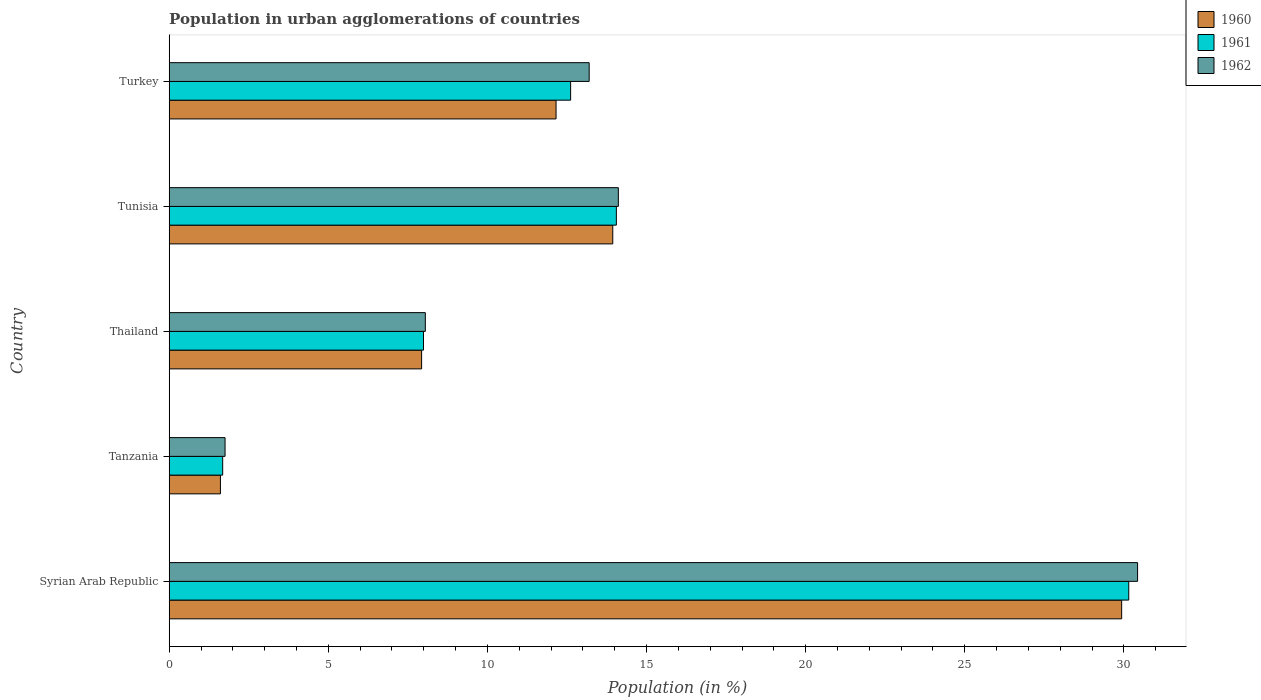How many different coloured bars are there?
Provide a short and direct response. 3. How many groups of bars are there?
Your answer should be very brief. 5. Are the number of bars per tick equal to the number of legend labels?
Offer a very short reply. Yes. How many bars are there on the 5th tick from the top?
Make the answer very short. 3. What is the label of the 2nd group of bars from the top?
Offer a very short reply. Tunisia. In how many cases, is the number of bars for a given country not equal to the number of legend labels?
Ensure brevity in your answer.  0. What is the percentage of population in urban agglomerations in 1961 in Turkey?
Make the answer very short. 12.61. Across all countries, what is the maximum percentage of population in urban agglomerations in 1961?
Your answer should be very brief. 30.15. Across all countries, what is the minimum percentage of population in urban agglomerations in 1961?
Your answer should be very brief. 1.68. In which country was the percentage of population in urban agglomerations in 1962 maximum?
Offer a very short reply. Syrian Arab Republic. In which country was the percentage of population in urban agglomerations in 1962 minimum?
Give a very brief answer. Tanzania. What is the total percentage of population in urban agglomerations in 1960 in the graph?
Make the answer very short. 65.56. What is the difference between the percentage of population in urban agglomerations in 1961 in Syrian Arab Republic and that in Turkey?
Offer a very short reply. 17.54. What is the difference between the percentage of population in urban agglomerations in 1960 in Thailand and the percentage of population in urban agglomerations in 1962 in Turkey?
Keep it short and to the point. -5.27. What is the average percentage of population in urban agglomerations in 1960 per country?
Offer a terse response. 13.11. What is the difference between the percentage of population in urban agglomerations in 1961 and percentage of population in urban agglomerations in 1960 in Tanzania?
Ensure brevity in your answer.  0.07. In how many countries, is the percentage of population in urban agglomerations in 1962 greater than 27 %?
Make the answer very short. 1. What is the ratio of the percentage of population in urban agglomerations in 1961 in Syrian Arab Republic to that in Thailand?
Your answer should be very brief. 3.77. Is the difference between the percentage of population in urban agglomerations in 1961 in Tanzania and Tunisia greater than the difference between the percentage of population in urban agglomerations in 1960 in Tanzania and Tunisia?
Keep it short and to the point. No. What is the difference between the highest and the second highest percentage of population in urban agglomerations in 1960?
Your answer should be compact. 15.99. What is the difference between the highest and the lowest percentage of population in urban agglomerations in 1961?
Provide a short and direct response. 28.47. In how many countries, is the percentage of population in urban agglomerations in 1961 greater than the average percentage of population in urban agglomerations in 1961 taken over all countries?
Provide a short and direct response. 2. What does the 3rd bar from the top in Tanzania represents?
Offer a very short reply. 1960. How many bars are there?
Your response must be concise. 15. Are all the bars in the graph horizontal?
Offer a terse response. Yes. What is the difference between two consecutive major ticks on the X-axis?
Provide a succinct answer. 5. Does the graph contain any zero values?
Your answer should be very brief. No. Does the graph contain grids?
Provide a succinct answer. No. Where does the legend appear in the graph?
Your answer should be very brief. Top right. How many legend labels are there?
Give a very brief answer. 3. What is the title of the graph?
Your answer should be compact. Population in urban agglomerations of countries. What is the label or title of the X-axis?
Ensure brevity in your answer.  Population (in %). What is the Population (in %) in 1960 in Syrian Arab Republic?
Your response must be concise. 29.93. What is the Population (in %) of 1961 in Syrian Arab Republic?
Your response must be concise. 30.15. What is the Population (in %) in 1962 in Syrian Arab Republic?
Provide a succinct answer. 30.43. What is the Population (in %) in 1960 in Tanzania?
Ensure brevity in your answer.  1.61. What is the Population (in %) in 1961 in Tanzania?
Give a very brief answer. 1.68. What is the Population (in %) in 1962 in Tanzania?
Keep it short and to the point. 1.76. What is the Population (in %) in 1960 in Thailand?
Provide a short and direct response. 7.93. What is the Population (in %) in 1961 in Thailand?
Offer a terse response. 7.99. What is the Population (in %) in 1962 in Thailand?
Your response must be concise. 8.05. What is the Population (in %) of 1960 in Tunisia?
Provide a succinct answer. 13.94. What is the Population (in %) in 1961 in Tunisia?
Offer a terse response. 14.05. What is the Population (in %) in 1962 in Tunisia?
Provide a short and direct response. 14.11. What is the Population (in %) in 1960 in Turkey?
Provide a short and direct response. 12.16. What is the Population (in %) in 1961 in Turkey?
Your answer should be very brief. 12.61. What is the Population (in %) of 1962 in Turkey?
Give a very brief answer. 13.2. Across all countries, what is the maximum Population (in %) of 1960?
Offer a terse response. 29.93. Across all countries, what is the maximum Population (in %) of 1961?
Your answer should be very brief. 30.15. Across all countries, what is the maximum Population (in %) of 1962?
Give a very brief answer. 30.43. Across all countries, what is the minimum Population (in %) of 1960?
Provide a short and direct response. 1.61. Across all countries, what is the minimum Population (in %) of 1961?
Ensure brevity in your answer.  1.68. Across all countries, what is the minimum Population (in %) of 1962?
Your response must be concise. 1.76. What is the total Population (in %) of 1960 in the graph?
Offer a very short reply. 65.56. What is the total Population (in %) of 1961 in the graph?
Ensure brevity in your answer.  66.49. What is the total Population (in %) in 1962 in the graph?
Your response must be concise. 67.54. What is the difference between the Population (in %) of 1960 in Syrian Arab Republic and that in Tanzania?
Make the answer very short. 28.32. What is the difference between the Population (in %) in 1961 in Syrian Arab Republic and that in Tanzania?
Give a very brief answer. 28.47. What is the difference between the Population (in %) in 1962 in Syrian Arab Republic and that in Tanzania?
Offer a very short reply. 28.67. What is the difference between the Population (in %) of 1960 in Syrian Arab Republic and that in Thailand?
Your answer should be compact. 22. What is the difference between the Population (in %) in 1961 in Syrian Arab Republic and that in Thailand?
Your answer should be compact. 22.16. What is the difference between the Population (in %) of 1962 in Syrian Arab Republic and that in Thailand?
Ensure brevity in your answer.  22.38. What is the difference between the Population (in %) of 1960 in Syrian Arab Republic and that in Tunisia?
Provide a short and direct response. 15.99. What is the difference between the Population (in %) in 1961 in Syrian Arab Republic and that in Tunisia?
Provide a succinct answer. 16.1. What is the difference between the Population (in %) of 1962 in Syrian Arab Republic and that in Tunisia?
Your response must be concise. 16.32. What is the difference between the Population (in %) of 1960 in Syrian Arab Republic and that in Turkey?
Your answer should be very brief. 17.77. What is the difference between the Population (in %) of 1961 in Syrian Arab Republic and that in Turkey?
Your answer should be compact. 17.54. What is the difference between the Population (in %) in 1962 in Syrian Arab Republic and that in Turkey?
Offer a very short reply. 17.23. What is the difference between the Population (in %) of 1960 in Tanzania and that in Thailand?
Your answer should be compact. -6.32. What is the difference between the Population (in %) of 1961 in Tanzania and that in Thailand?
Ensure brevity in your answer.  -6.31. What is the difference between the Population (in %) of 1962 in Tanzania and that in Thailand?
Ensure brevity in your answer.  -6.29. What is the difference between the Population (in %) in 1960 in Tanzania and that in Tunisia?
Your answer should be compact. -12.33. What is the difference between the Population (in %) in 1961 in Tanzania and that in Tunisia?
Your response must be concise. -12.37. What is the difference between the Population (in %) of 1962 in Tanzania and that in Tunisia?
Provide a succinct answer. -12.36. What is the difference between the Population (in %) of 1960 in Tanzania and that in Turkey?
Give a very brief answer. -10.55. What is the difference between the Population (in %) of 1961 in Tanzania and that in Turkey?
Keep it short and to the point. -10.93. What is the difference between the Population (in %) of 1962 in Tanzania and that in Turkey?
Ensure brevity in your answer.  -11.44. What is the difference between the Population (in %) in 1960 in Thailand and that in Tunisia?
Ensure brevity in your answer.  -6.01. What is the difference between the Population (in %) of 1961 in Thailand and that in Tunisia?
Offer a terse response. -6.06. What is the difference between the Population (in %) of 1962 in Thailand and that in Tunisia?
Your response must be concise. -6.07. What is the difference between the Population (in %) of 1960 in Thailand and that in Turkey?
Offer a very short reply. -4.22. What is the difference between the Population (in %) of 1961 in Thailand and that in Turkey?
Keep it short and to the point. -4.62. What is the difference between the Population (in %) of 1962 in Thailand and that in Turkey?
Make the answer very short. -5.15. What is the difference between the Population (in %) in 1960 in Tunisia and that in Turkey?
Make the answer very short. 1.78. What is the difference between the Population (in %) of 1961 in Tunisia and that in Turkey?
Offer a terse response. 1.44. What is the difference between the Population (in %) in 1960 in Syrian Arab Republic and the Population (in %) in 1961 in Tanzania?
Make the answer very short. 28.25. What is the difference between the Population (in %) of 1960 in Syrian Arab Republic and the Population (in %) of 1962 in Tanzania?
Offer a very short reply. 28.17. What is the difference between the Population (in %) of 1961 in Syrian Arab Republic and the Population (in %) of 1962 in Tanzania?
Offer a very short reply. 28.4. What is the difference between the Population (in %) of 1960 in Syrian Arab Republic and the Population (in %) of 1961 in Thailand?
Offer a terse response. 21.94. What is the difference between the Population (in %) of 1960 in Syrian Arab Republic and the Population (in %) of 1962 in Thailand?
Keep it short and to the point. 21.88. What is the difference between the Population (in %) in 1961 in Syrian Arab Republic and the Population (in %) in 1962 in Thailand?
Offer a very short reply. 22.1. What is the difference between the Population (in %) in 1960 in Syrian Arab Republic and the Population (in %) in 1961 in Tunisia?
Your answer should be very brief. 15.88. What is the difference between the Population (in %) of 1960 in Syrian Arab Republic and the Population (in %) of 1962 in Tunisia?
Your answer should be compact. 15.82. What is the difference between the Population (in %) of 1961 in Syrian Arab Republic and the Population (in %) of 1962 in Tunisia?
Provide a succinct answer. 16.04. What is the difference between the Population (in %) of 1960 in Syrian Arab Republic and the Population (in %) of 1961 in Turkey?
Provide a short and direct response. 17.31. What is the difference between the Population (in %) in 1960 in Syrian Arab Republic and the Population (in %) in 1962 in Turkey?
Give a very brief answer. 16.73. What is the difference between the Population (in %) of 1961 in Syrian Arab Republic and the Population (in %) of 1962 in Turkey?
Ensure brevity in your answer.  16.95. What is the difference between the Population (in %) in 1960 in Tanzania and the Population (in %) in 1961 in Thailand?
Offer a terse response. -6.38. What is the difference between the Population (in %) in 1960 in Tanzania and the Population (in %) in 1962 in Thailand?
Your answer should be very brief. -6.44. What is the difference between the Population (in %) in 1961 in Tanzania and the Population (in %) in 1962 in Thailand?
Offer a very short reply. -6.37. What is the difference between the Population (in %) of 1960 in Tanzania and the Population (in %) of 1961 in Tunisia?
Give a very brief answer. -12.44. What is the difference between the Population (in %) of 1960 in Tanzania and the Population (in %) of 1962 in Tunisia?
Give a very brief answer. -12.5. What is the difference between the Population (in %) of 1961 in Tanzania and the Population (in %) of 1962 in Tunisia?
Give a very brief answer. -12.43. What is the difference between the Population (in %) in 1960 in Tanzania and the Population (in %) in 1961 in Turkey?
Offer a very short reply. -11. What is the difference between the Population (in %) in 1960 in Tanzania and the Population (in %) in 1962 in Turkey?
Offer a very short reply. -11.59. What is the difference between the Population (in %) in 1961 in Tanzania and the Population (in %) in 1962 in Turkey?
Offer a very short reply. -11.52. What is the difference between the Population (in %) in 1960 in Thailand and the Population (in %) in 1961 in Tunisia?
Provide a succinct answer. -6.12. What is the difference between the Population (in %) of 1960 in Thailand and the Population (in %) of 1962 in Tunisia?
Your answer should be compact. -6.18. What is the difference between the Population (in %) of 1961 in Thailand and the Population (in %) of 1962 in Tunisia?
Offer a terse response. -6.12. What is the difference between the Population (in %) in 1960 in Thailand and the Population (in %) in 1961 in Turkey?
Give a very brief answer. -4.68. What is the difference between the Population (in %) in 1960 in Thailand and the Population (in %) in 1962 in Turkey?
Give a very brief answer. -5.27. What is the difference between the Population (in %) in 1961 in Thailand and the Population (in %) in 1962 in Turkey?
Ensure brevity in your answer.  -5.21. What is the difference between the Population (in %) in 1960 in Tunisia and the Population (in %) in 1961 in Turkey?
Offer a very short reply. 1.32. What is the difference between the Population (in %) in 1960 in Tunisia and the Population (in %) in 1962 in Turkey?
Provide a short and direct response. 0.74. What is the difference between the Population (in %) of 1961 in Tunisia and the Population (in %) of 1962 in Turkey?
Your answer should be very brief. 0.85. What is the average Population (in %) in 1960 per country?
Give a very brief answer. 13.11. What is the average Population (in %) of 1961 per country?
Keep it short and to the point. 13.3. What is the average Population (in %) of 1962 per country?
Your response must be concise. 13.51. What is the difference between the Population (in %) of 1960 and Population (in %) of 1961 in Syrian Arab Republic?
Provide a succinct answer. -0.22. What is the difference between the Population (in %) of 1960 and Population (in %) of 1962 in Syrian Arab Republic?
Provide a succinct answer. -0.5. What is the difference between the Population (in %) of 1961 and Population (in %) of 1962 in Syrian Arab Republic?
Provide a short and direct response. -0.28. What is the difference between the Population (in %) in 1960 and Population (in %) in 1961 in Tanzania?
Your answer should be compact. -0.07. What is the difference between the Population (in %) of 1960 and Population (in %) of 1962 in Tanzania?
Offer a very short reply. -0.15. What is the difference between the Population (in %) of 1961 and Population (in %) of 1962 in Tanzania?
Ensure brevity in your answer.  -0.07. What is the difference between the Population (in %) of 1960 and Population (in %) of 1961 in Thailand?
Keep it short and to the point. -0.06. What is the difference between the Population (in %) of 1960 and Population (in %) of 1962 in Thailand?
Make the answer very short. -0.12. What is the difference between the Population (in %) of 1961 and Population (in %) of 1962 in Thailand?
Make the answer very short. -0.06. What is the difference between the Population (in %) in 1960 and Population (in %) in 1961 in Tunisia?
Keep it short and to the point. -0.11. What is the difference between the Population (in %) in 1960 and Population (in %) in 1962 in Tunisia?
Your answer should be compact. -0.18. What is the difference between the Population (in %) in 1961 and Population (in %) in 1962 in Tunisia?
Your answer should be very brief. -0.06. What is the difference between the Population (in %) of 1960 and Population (in %) of 1961 in Turkey?
Give a very brief answer. -0.46. What is the difference between the Population (in %) of 1960 and Population (in %) of 1962 in Turkey?
Offer a very short reply. -1.04. What is the difference between the Population (in %) in 1961 and Population (in %) in 1962 in Turkey?
Provide a short and direct response. -0.58. What is the ratio of the Population (in %) in 1960 in Syrian Arab Republic to that in Tanzania?
Provide a short and direct response. 18.6. What is the ratio of the Population (in %) of 1961 in Syrian Arab Republic to that in Tanzania?
Provide a succinct answer. 17.94. What is the ratio of the Population (in %) in 1962 in Syrian Arab Republic to that in Tanzania?
Offer a very short reply. 17.34. What is the ratio of the Population (in %) of 1960 in Syrian Arab Republic to that in Thailand?
Offer a terse response. 3.77. What is the ratio of the Population (in %) of 1961 in Syrian Arab Republic to that in Thailand?
Your answer should be compact. 3.77. What is the ratio of the Population (in %) in 1962 in Syrian Arab Republic to that in Thailand?
Keep it short and to the point. 3.78. What is the ratio of the Population (in %) of 1960 in Syrian Arab Republic to that in Tunisia?
Provide a succinct answer. 2.15. What is the ratio of the Population (in %) in 1961 in Syrian Arab Republic to that in Tunisia?
Make the answer very short. 2.15. What is the ratio of the Population (in %) of 1962 in Syrian Arab Republic to that in Tunisia?
Offer a terse response. 2.16. What is the ratio of the Population (in %) in 1960 in Syrian Arab Republic to that in Turkey?
Offer a very short reply. 2.46. What is the ratio of the Population (in %) of 1961 in Syrian Arab Republic to that in Turkey?
Offer a terse response. 2.39. What is the ratio of the Population (in %) in 1962 in Syrian Arab Republic to that in Turkey?
Your response must be concise. 2.31. What is the ratio of the Population (in %) in 1960 in Tanzania to that in Thailand?
Offer a terse response. 0.2. What is the ratio of the Population (in %) of 1961 in Tanzania to that in Thailand?
Your answer should be very brief. 0.21. What is the ratio of the Population (in %) in 1962 in Tanzania to that in Thailand?
Offer a very short reply. 0.22. What is the ratio of the Population (in %) in 1960 in Tanzania to that in Tunisia?
Offer a terse response. 0.12. What is the ratio of the Population (in %) in 1961 in Tanzania to that in Tunisia?
Provide a succinct answer. 0.12. What is the ratio of the Population (in %) in 1962 in Tanzania to that in Tunisia?
Make the answer very short. 0.12. What is the ratio of the Population (in %) in 1960 in Tanzania to that in Turkey?
Provide a short and direct response. 0.13. What is the ratio of the Population (in %) in 1961 in Tanzania to that in Turkey?
Offer a terse response. 0.13. What is the ratio of the Population (in %) in 1962 in Tanzania to that in Turkey?
Offer a very short reply. 0.13. What is the ratio of the Population (in %) in 1960 in Thailand to that in Tunisia?
Your answer should be very brief. 0.57. What is the ratio of the Population (in %) in 1961 in Thailand to that in Tunisia?
Give a very brief answer. 0.57. What is the ratio of the Population (in %) of 1962 in Thailand to that in Tunisia?
Make the answer very short. 0.57. What is the ratio of the Population (in %) in 1960 in Thailand to that in Turkey?
Provide a succinct answer. 0.65. What is the ratio of the Population (in %) in 1961 in Thailand to that in Turkey?
Give a very brief answer. 0.63. What is the ratio of the Population (in %) in 1962 in Thailand to that in Turkey?
Offer a terse response. 0.61. What is the ratio of the Population (in %) in 1960 in Tunisia to that in Turkey?
Ensure brevity in your answer.  1.15. What is the ratio of the Population (in %) of 1961 in Tunisia to that in Turkey?
Your answer should be compact. 1.11. What is the ratio of the Population (in %) of 1962 in Tunisia to that in Turkey?
Keep it short and to the point. 1.07. What is the difference between the highest and the second highest Population (in %) in 1960?
Provide a short and direct response. 15.99. What is the difference between the highest and the second highest Population (in %) in 1961?
Provide a short and direct response. 16.1. What is the difference between the highest and the second highest Population (in %) in 1962?
Make the answer very short. 16.32. What is the difference between the highest and the lowest Population (in %) of 1960?
Make the answer very short. 28.32. What is the difference between the highest and the lowest Population (in %) in 1961?
Keep it short and to the point. 28.47. What is the difference between the highest and the lowest Population (in %) of 1962?
Provide a succinct answer. 28.67. 